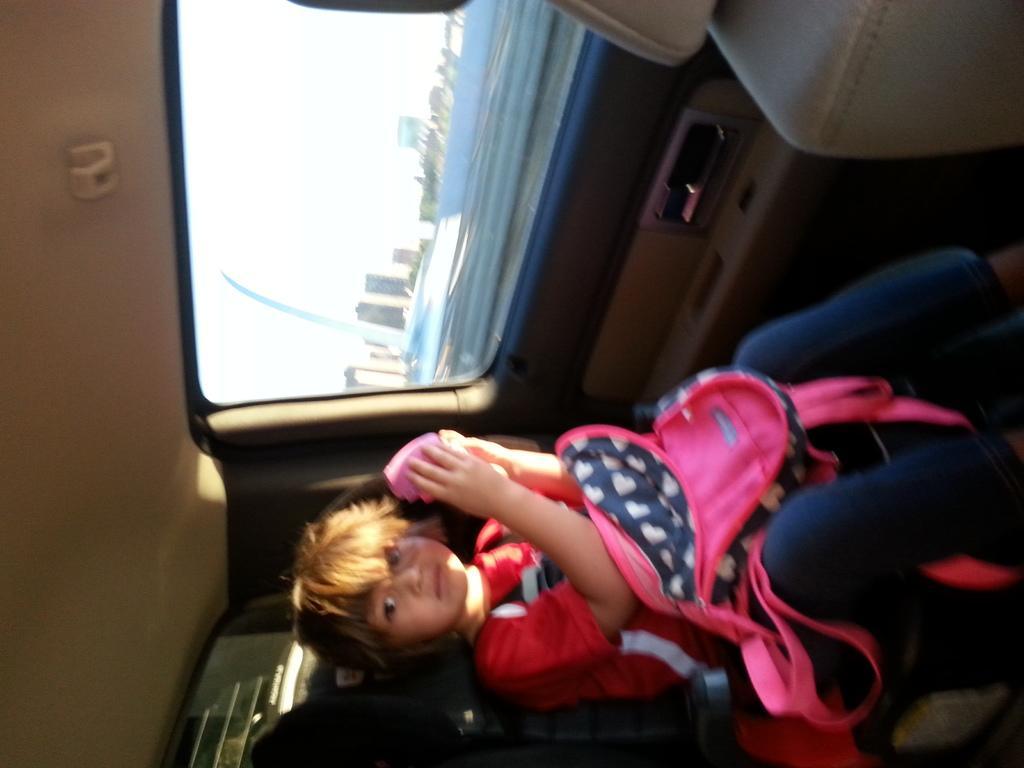Describe this image in one or two sentences. The girl at the bottom of the picture wearing red t-shirt is holding a pink color box in her hands and she is sitting in the car. We even see a pink and blue color bag on her laps. Beside her, we see a window from which we can see trees and buildings and we even see the sky. This picture is clicked inside the car. 